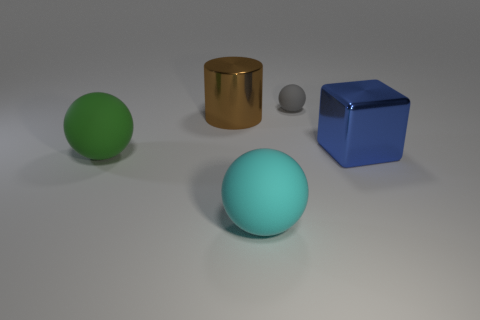Add 4 brown cylinders. How many objects exist? 9 Subtract all cylinders. How many objects are left? 4 Subtract all large blocks. Subtract all tiny balls. How many objects are left? 3 Add 1 green matte things. How many green matte things are left? 2 Add 3 gray balls. How many gray balls exist? 4 Subtract 1 green balls. How many objects are left? 4 